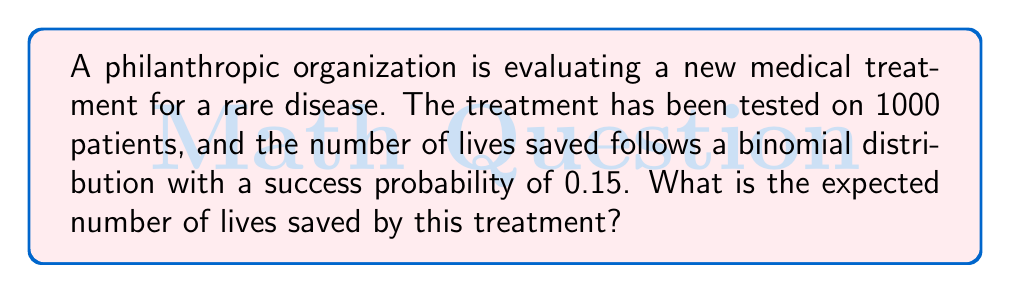Provide a solution to this math problem. To solve this problem, we need to use the properties of the binomial distribution and the concept of expected value.

1) The binomial distribution is characterized by two parameters:
   $n$ = number of trials
   $p$ = probability of success on each trial

2) In this case:
   $n = 1000$ (number of patients)
   $p = 0.15$ (probability of saving a life)

3) The expected value (mean) of a binomial distribution is given by the formula:

   $$E(X) = np$$

4) Substituting our values:

   $$E(X) = 1000 \times 0.15 = 150$$

5) Therefore, the expected number of lives saved is 150.

This means that, on average, we can expect the treatment to save 150 lives out of 1000 patients treated.
Answer: 150 lives 